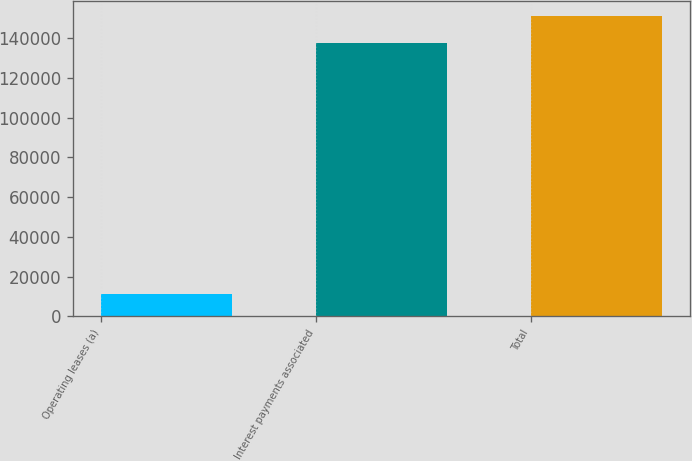Convert chart to OTSL. <chart><loc_0><loc_0><loc_500><loc_500><bar_chart><fcel>Operating leases (a)<fcel>Interest payments associated<fcel>Total<nl><fcel>11472<fcel>137450<fcel>151195<nl></chart> 